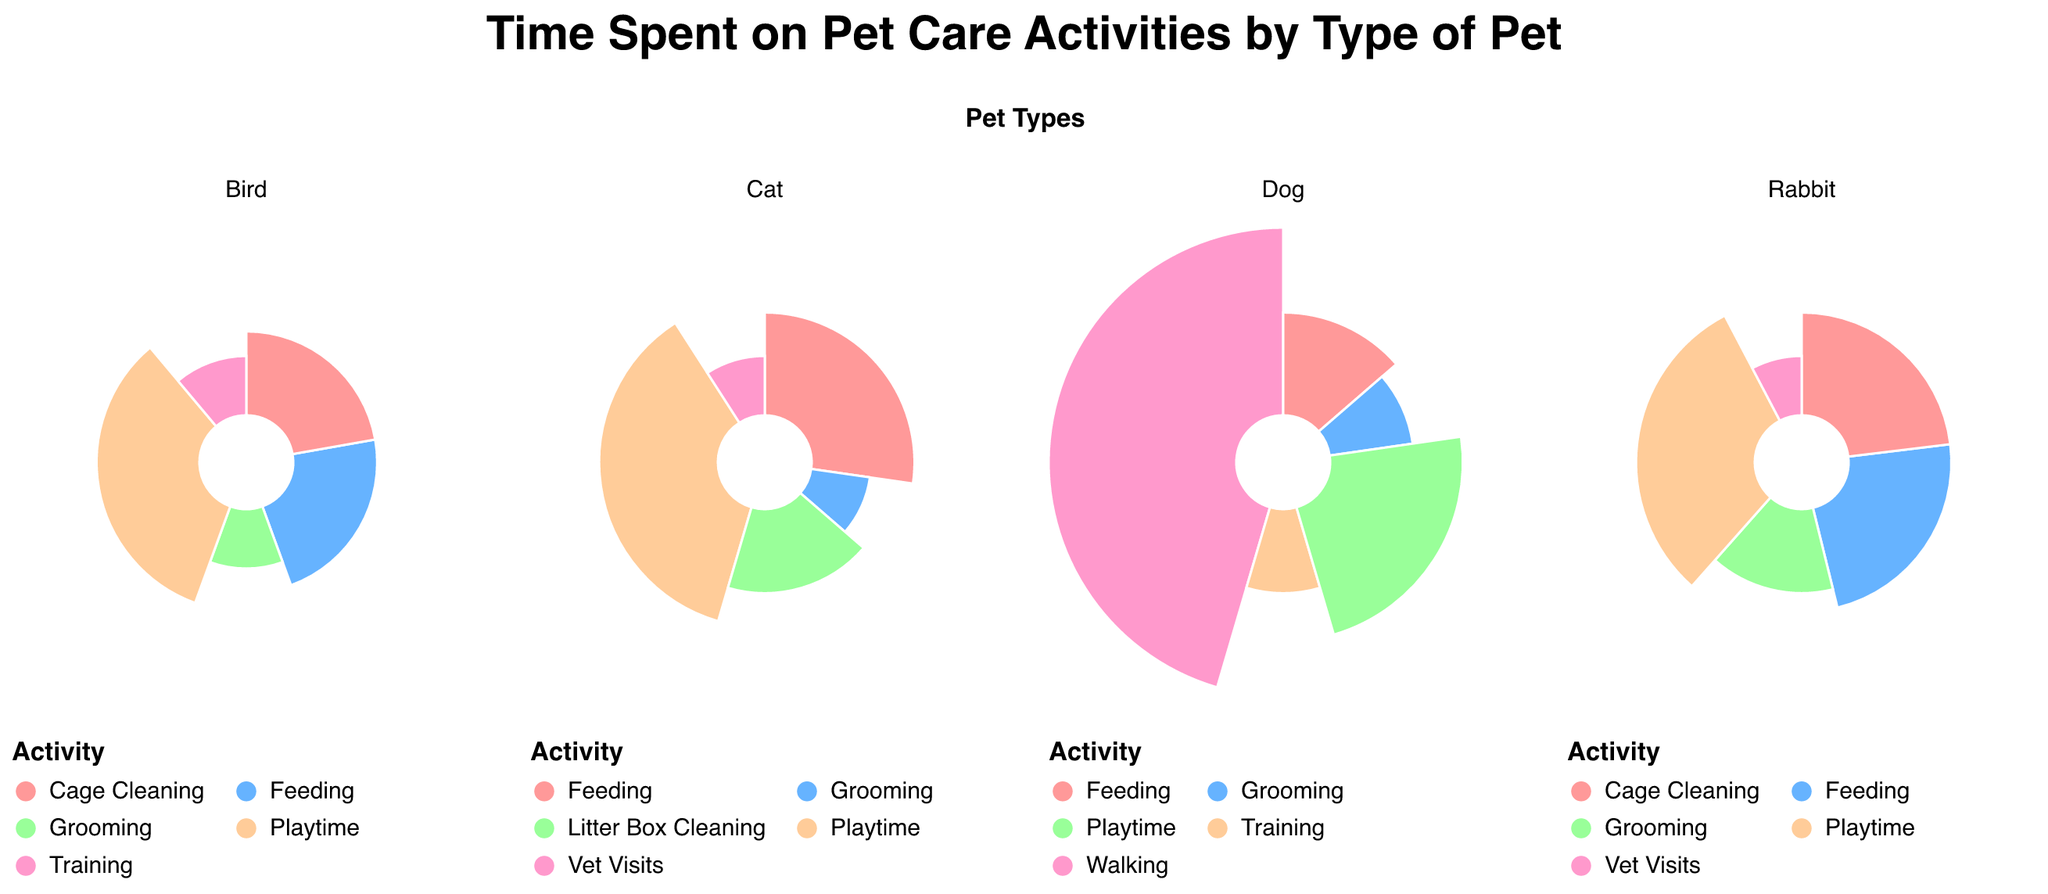What's the total amount of time spent on dog care activities in a week? To find the total time spent on dog care activities, sum the time for all activities listed under "Dog". That is, Walking (10) + Feeding (3) + Grooming (2) + Training (2) + Playtime (5) = 22 hours/week.
Answer: 22 hours Which activity requires the most time for dogs? To determine the activity that requires the most time for dogs, compare the times for all activities listed. Walking requires 10 hours, which is the highest.
Answer: Walking Comparing cats and dogs, which pet requires more time for grooming? To compare grooming times for cats and dogs, observe the grooming time for each pet type. Cats require 1 hour and dogs require 2 hours for grooming.
Answer: Dogs Which two pet care activities take the same amount of time for birds and rabbits? Identify activities with equal times by comparing all activities between birds and rabbits. Both Cage Cleaning and Vet Visits require 2 hours for birds and rabbits.
Answer: Cage Cleaning and Vet Visits What is the smallest amount of weekly time spent on any activity for rabbits? Check the time spent on each rabbit care activity to find the minimum. Grooming and Vet Visits both require 1 hour each per week.
Answer: 1 hour How much time do cats and rabbits spend combined on feeding? Add the feeding times for cats (3 hours) and rabbits (3 hours). 3 + 3 = 6 hours.
Answer: 6 hours Compare the total playtime across all pet types. Which pet has the highest total playtime? Sum the playtime hours for each pet type: Dogs (5), Cats (4), Rabbits (4), Birds (3). The highest total is for dogs with 5 hours.
Answer: Dogs By how many hours do dogs spend more time on playtime compared to birds? Compare the playtime hours: Dogs (5 hours) and Birds (3 hours). Subtract Bird's playtime from Dog's playtime: 5 - 3 = 2 hours.
Answer: 2 hours Is the time spent on feeding the same for any two different pets? Compare the feeding hours for all pets: Dogs (3), Cats (3), Rabbits (3), Birds (2). Dogs, Cats, and Rabbits all spend the same amount of time (3 hours) on feeding.
Answer: Yes 